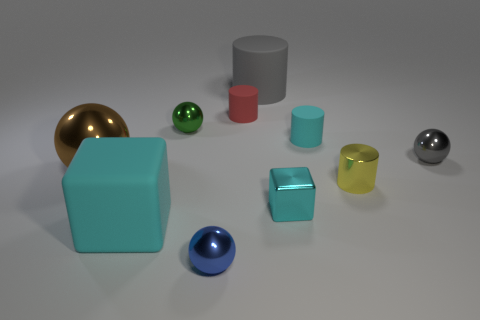Subtract all small shiny cylinders. How many cylinders are left? 3 Subtract all cubes. How many objects are left? 8 Add 5 small metallic cylinders. How many small metallic cylinders exist? 6 Subtract all red cylinders. How many cylinders are left? 3 Subtract 1 green spheres. How many objects are left? 9 Subtract 4 cylinders. How many cylinders are left? 0 Subtract all green blocks. Subtract all green cylinders. How many blocks are left? 2 Subtract all red spheres. How many red cylinders are left? 1 Subtract all big metal things. Subtract all brown rubber objects. How many objects are left? 9 Add 5 red rubber things. How many red rubber things are left? 6 